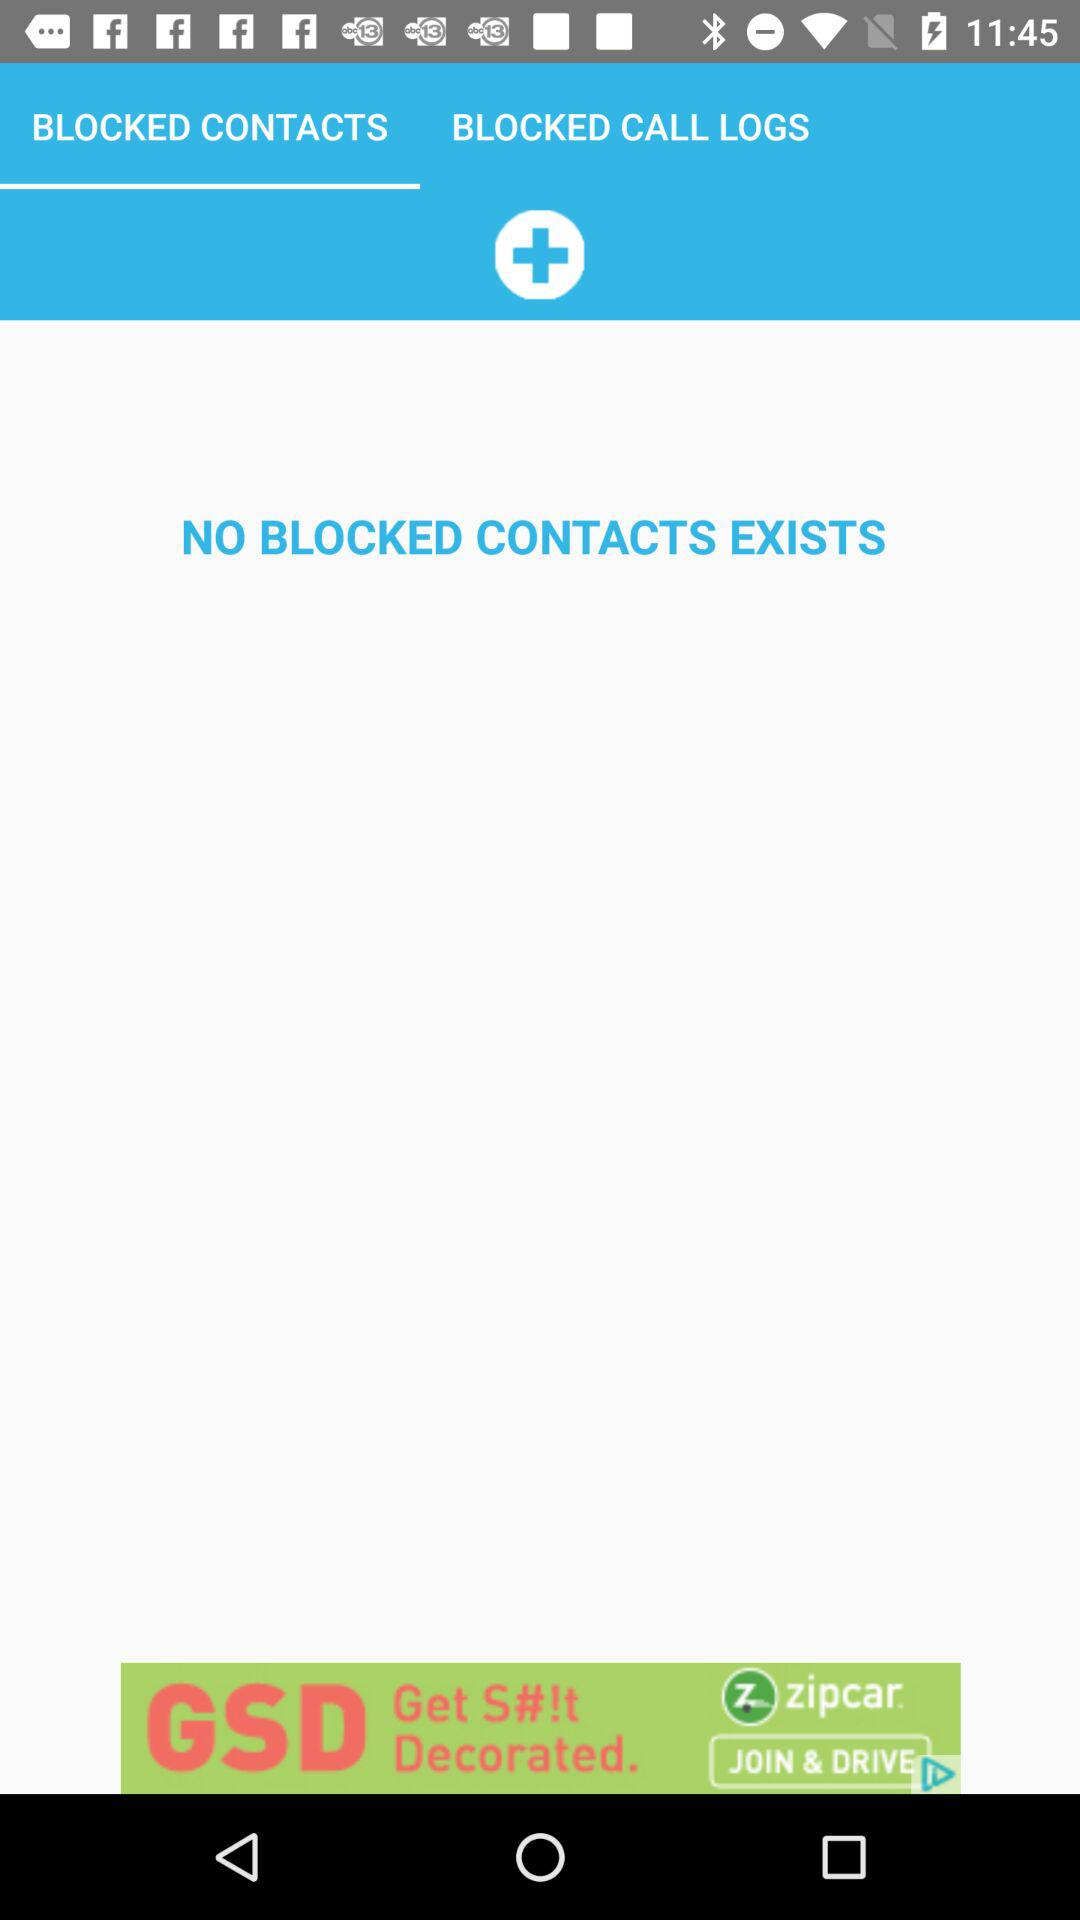How many blocked contacts logs are there?
Answer the question using a single word or phrase. 0 